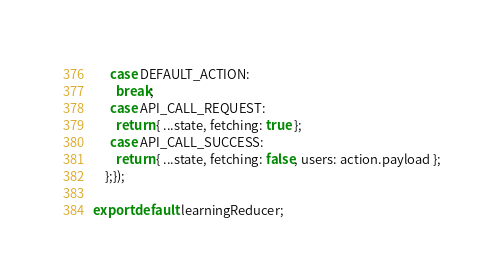<code> <loc_0><loc_0><loc_500><loc_500><_JavaScript_>      case DEFAULT_ACTION:
        break;
      case API_CALL_REQUEST:
        return { ...state, fetching: true };
      case API_CALL_SUCCESS:
        return { ...state, fetching: false, users: action.payload };
    };});

export default learningReducer;
</code> 